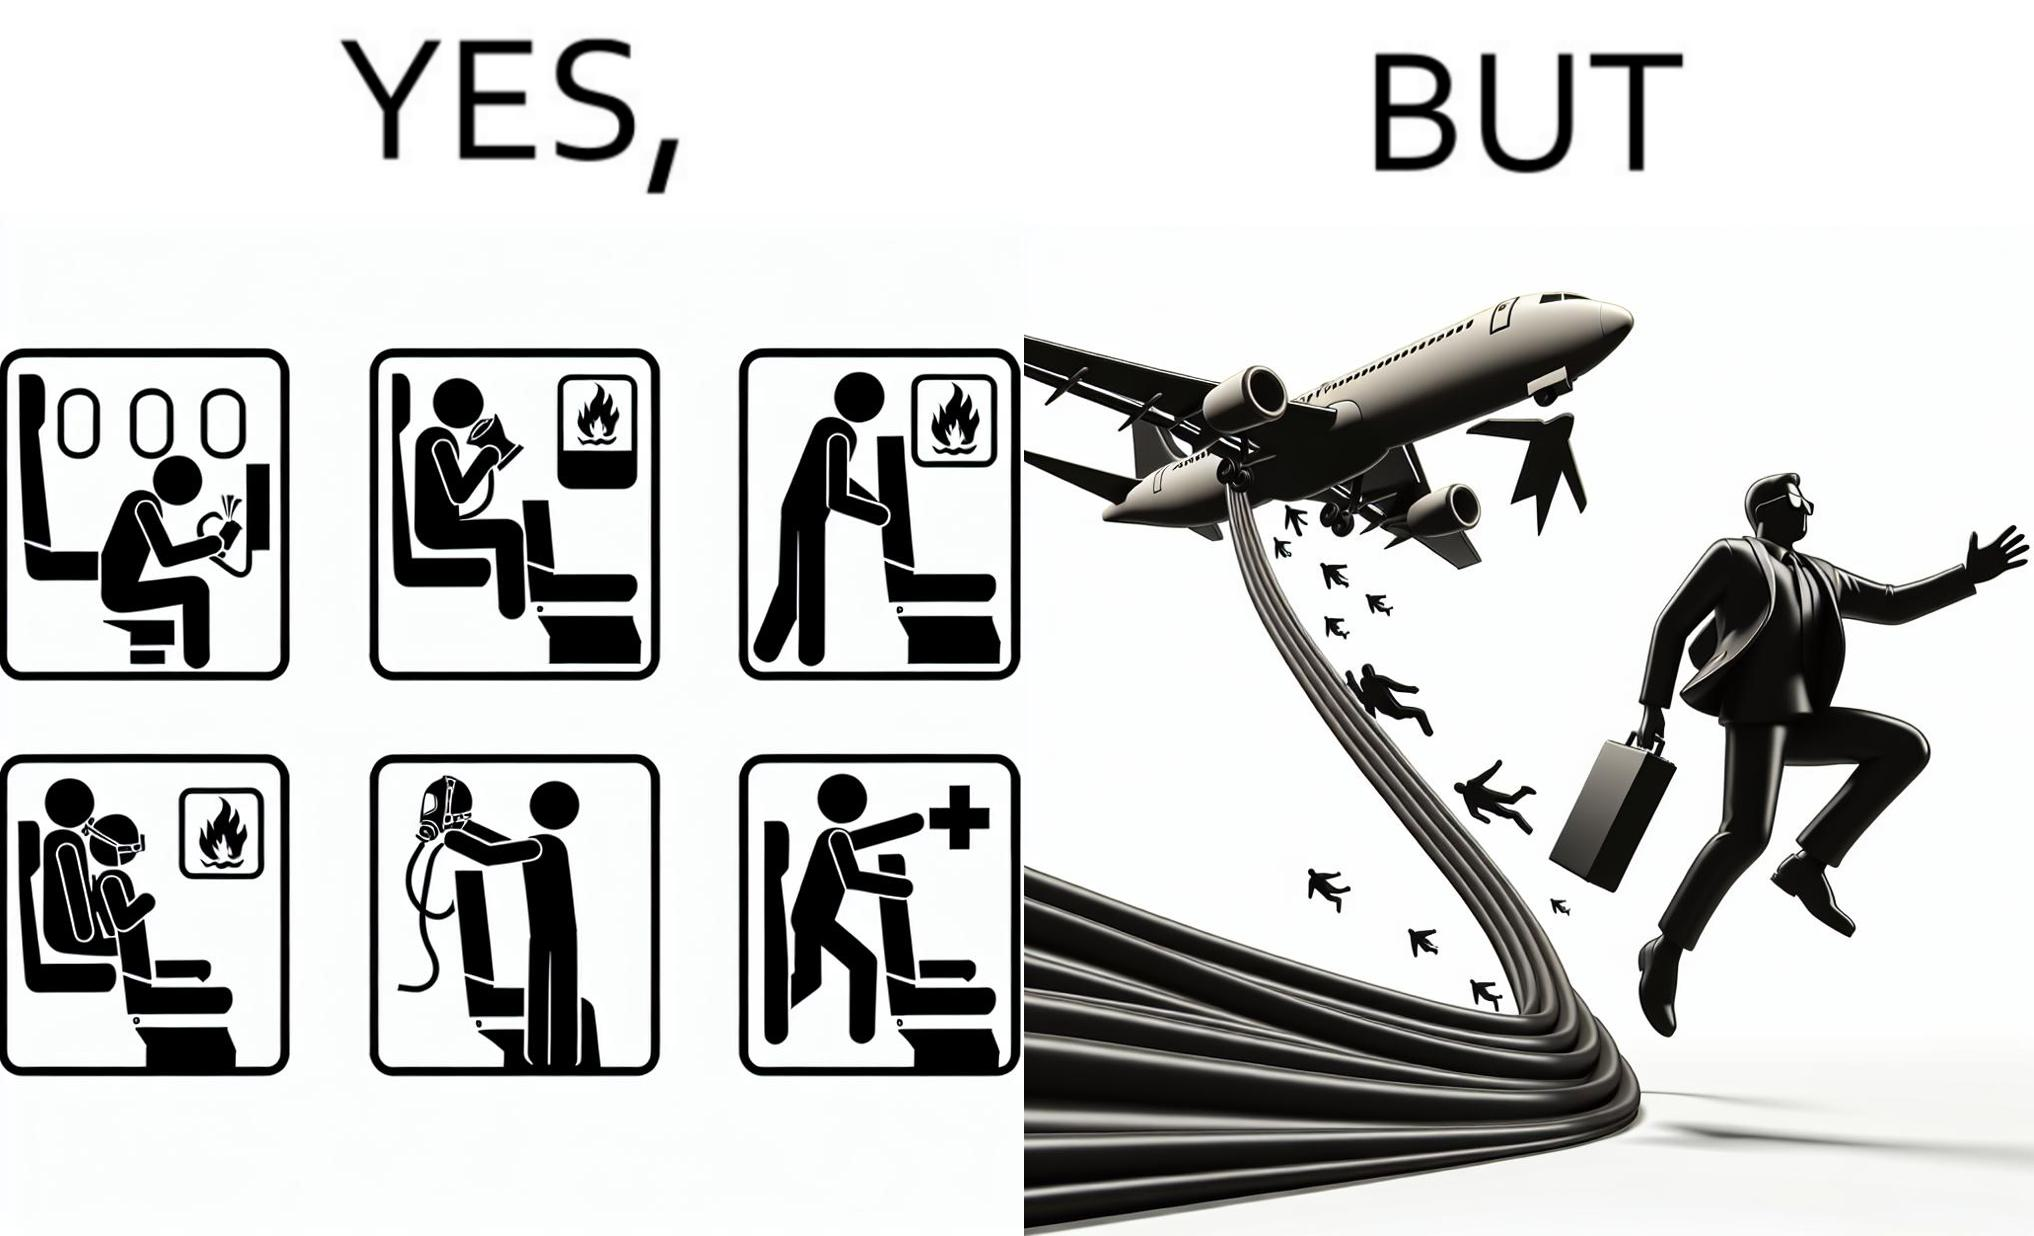Would you classify this image as satirical? Yes, this image is satirical. 